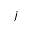<formula> <loc_0><loc_0><loc_500><loc_500>j</formula> 